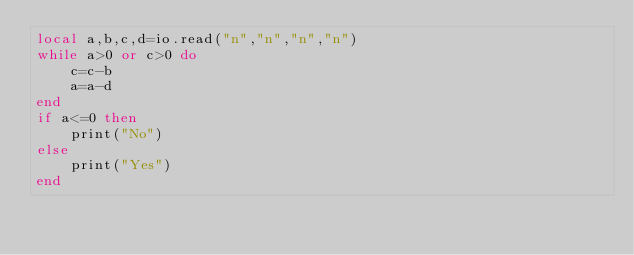Convert code to text. <code><loc_0><loc_0><loc_500><loc_500><_Lua_>local a,b,c,d=io.read("n","n","n","n")
while a>0 or c>0 do
    c=c-b
    a=a-d
end
if a<=0 then
    print("No")
else
    print("Yes")
end</code> 